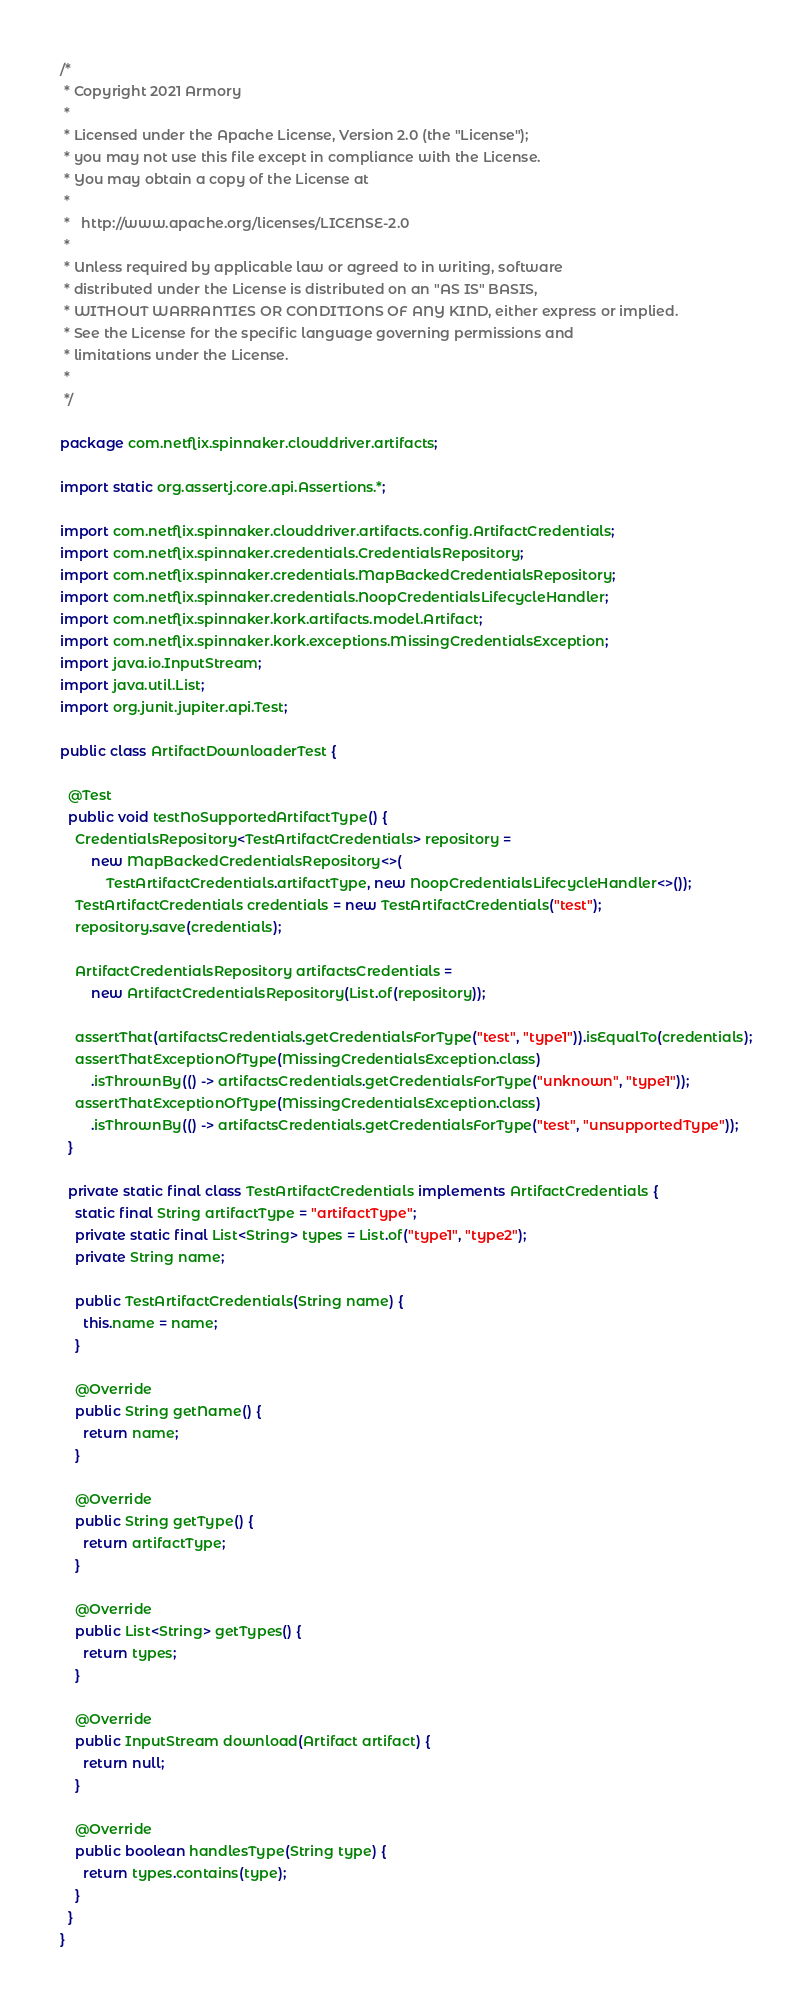<code> <loc_0><loc_0><loc_500><loc_500><_Java_>/*
 * Copyright 2021 Armory
 *
 * Licensed under the Apache License, Version 2.0 (the "License");
 * you may not use this file except in compliance with the License.
 * You may obtain a copy of the License at
 *
 *   http://www.apache.org/licenses/LICENSE-2.0
 *
 * Unless required by applicable law or agreed to in writing, software
 * distributed under the License is distributed on an "AS IS" BASIS,
 * WITHOUT WARRANTIES OR CONDITIONS OF ANY KIND, either express or implied.
 * See the License for the specific language governing permissions and
 * limitations under the License.
 *
 */

package com.netflix.spinnaker.clouddriver.artifacts;

import static org.assertj.core.api.Assertions.*;

import com.netflix.spinnaker.clouddriver.artifacts.config.ArtifactCredentials;
import com.netflix.spinnaker.credentials.CredentialsRepository;
import com.netflix.spinnaker.credentials.MapBackedCredentialsRepository;
import com.netflix.spinnaker.credentials.NoopCredentialsLifecycleHandler;
import com.netflix.spinnaker.kork.artifacts.model.Artifact;
import com.netflix.spinnaker.kork.exceptions.MissingCredentialsException;
import java.io.InputStream;
import java.util.List;
import org.junit.jupiter.api.Test;

public class ArtifactDownloaderTest {

  @Test
  public void testNoSupportedArtifactType() {
    CredentialsRepository<TestArtifactCredentials> repository =
        new MapBackedCredentialsRepository<>(
            TestArtifactCredentials.artifactType, new NoopCredentialsLifecycleHandler<>());
    TestArtifactCredentials credentials = new TestArtifactCredentials("test");
    repository.save(credentials);

    ArtifactCredentialsRepository artifactsCredentials =
        new ArtifactCredentialsRepository(List.of(repository));

    assertThat(artifactsCredentials.getCredentialsForType("test", "type1")).isEqualTo(credentials);
    assertThatExceptionOfType(MissingCredentialsException.class)
        .isThrownBy(() -> artifactsCredentials.getCredentialsForType("unknown", "type1"));
    assertThatExceptionOfType(MissingCredentialsException.class)
        .isThrownBy(() -> artifactsCredentials.getCredentialsForType("test", "unsupportedType"));
  }

  private static final class TestArtifactCredentials implements ArtifactCredentials {
    static final String artifactType = "artifactType";
    private static final List<String> types = List.of("type1", "type2");
    private String name;

    public TestArtifactCredentials(String name) {
      this.name = name;
    }

    @Override
    public String getName() {
      return name;
    }

    @Override
    public String getType() {
      return artifactType;
    }

    @Override
    public List<String> getTypes() {
      return types;
    }

    @Override
    public InputStream download(Artifact artifact) {
      return null;
    }

    @Override
    public boolean handlesType(String type) {
      return types.contains(type);
    }
  }
}
</code> 